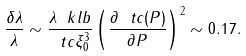Convert formula to latex. <formula><loc_0><loc_0><loc_500><loc_500>\frac { \delta \lambda } { \lambda } \sim \frac { \lambda \ k l b } { \ t c \xi _ { 0 } ^ { 3 } } \left ( \frac { \partial \ t c ( P ) } { \partial P } \right ) ^ { 2 } \sim 0 . 1 7 .</formula> 